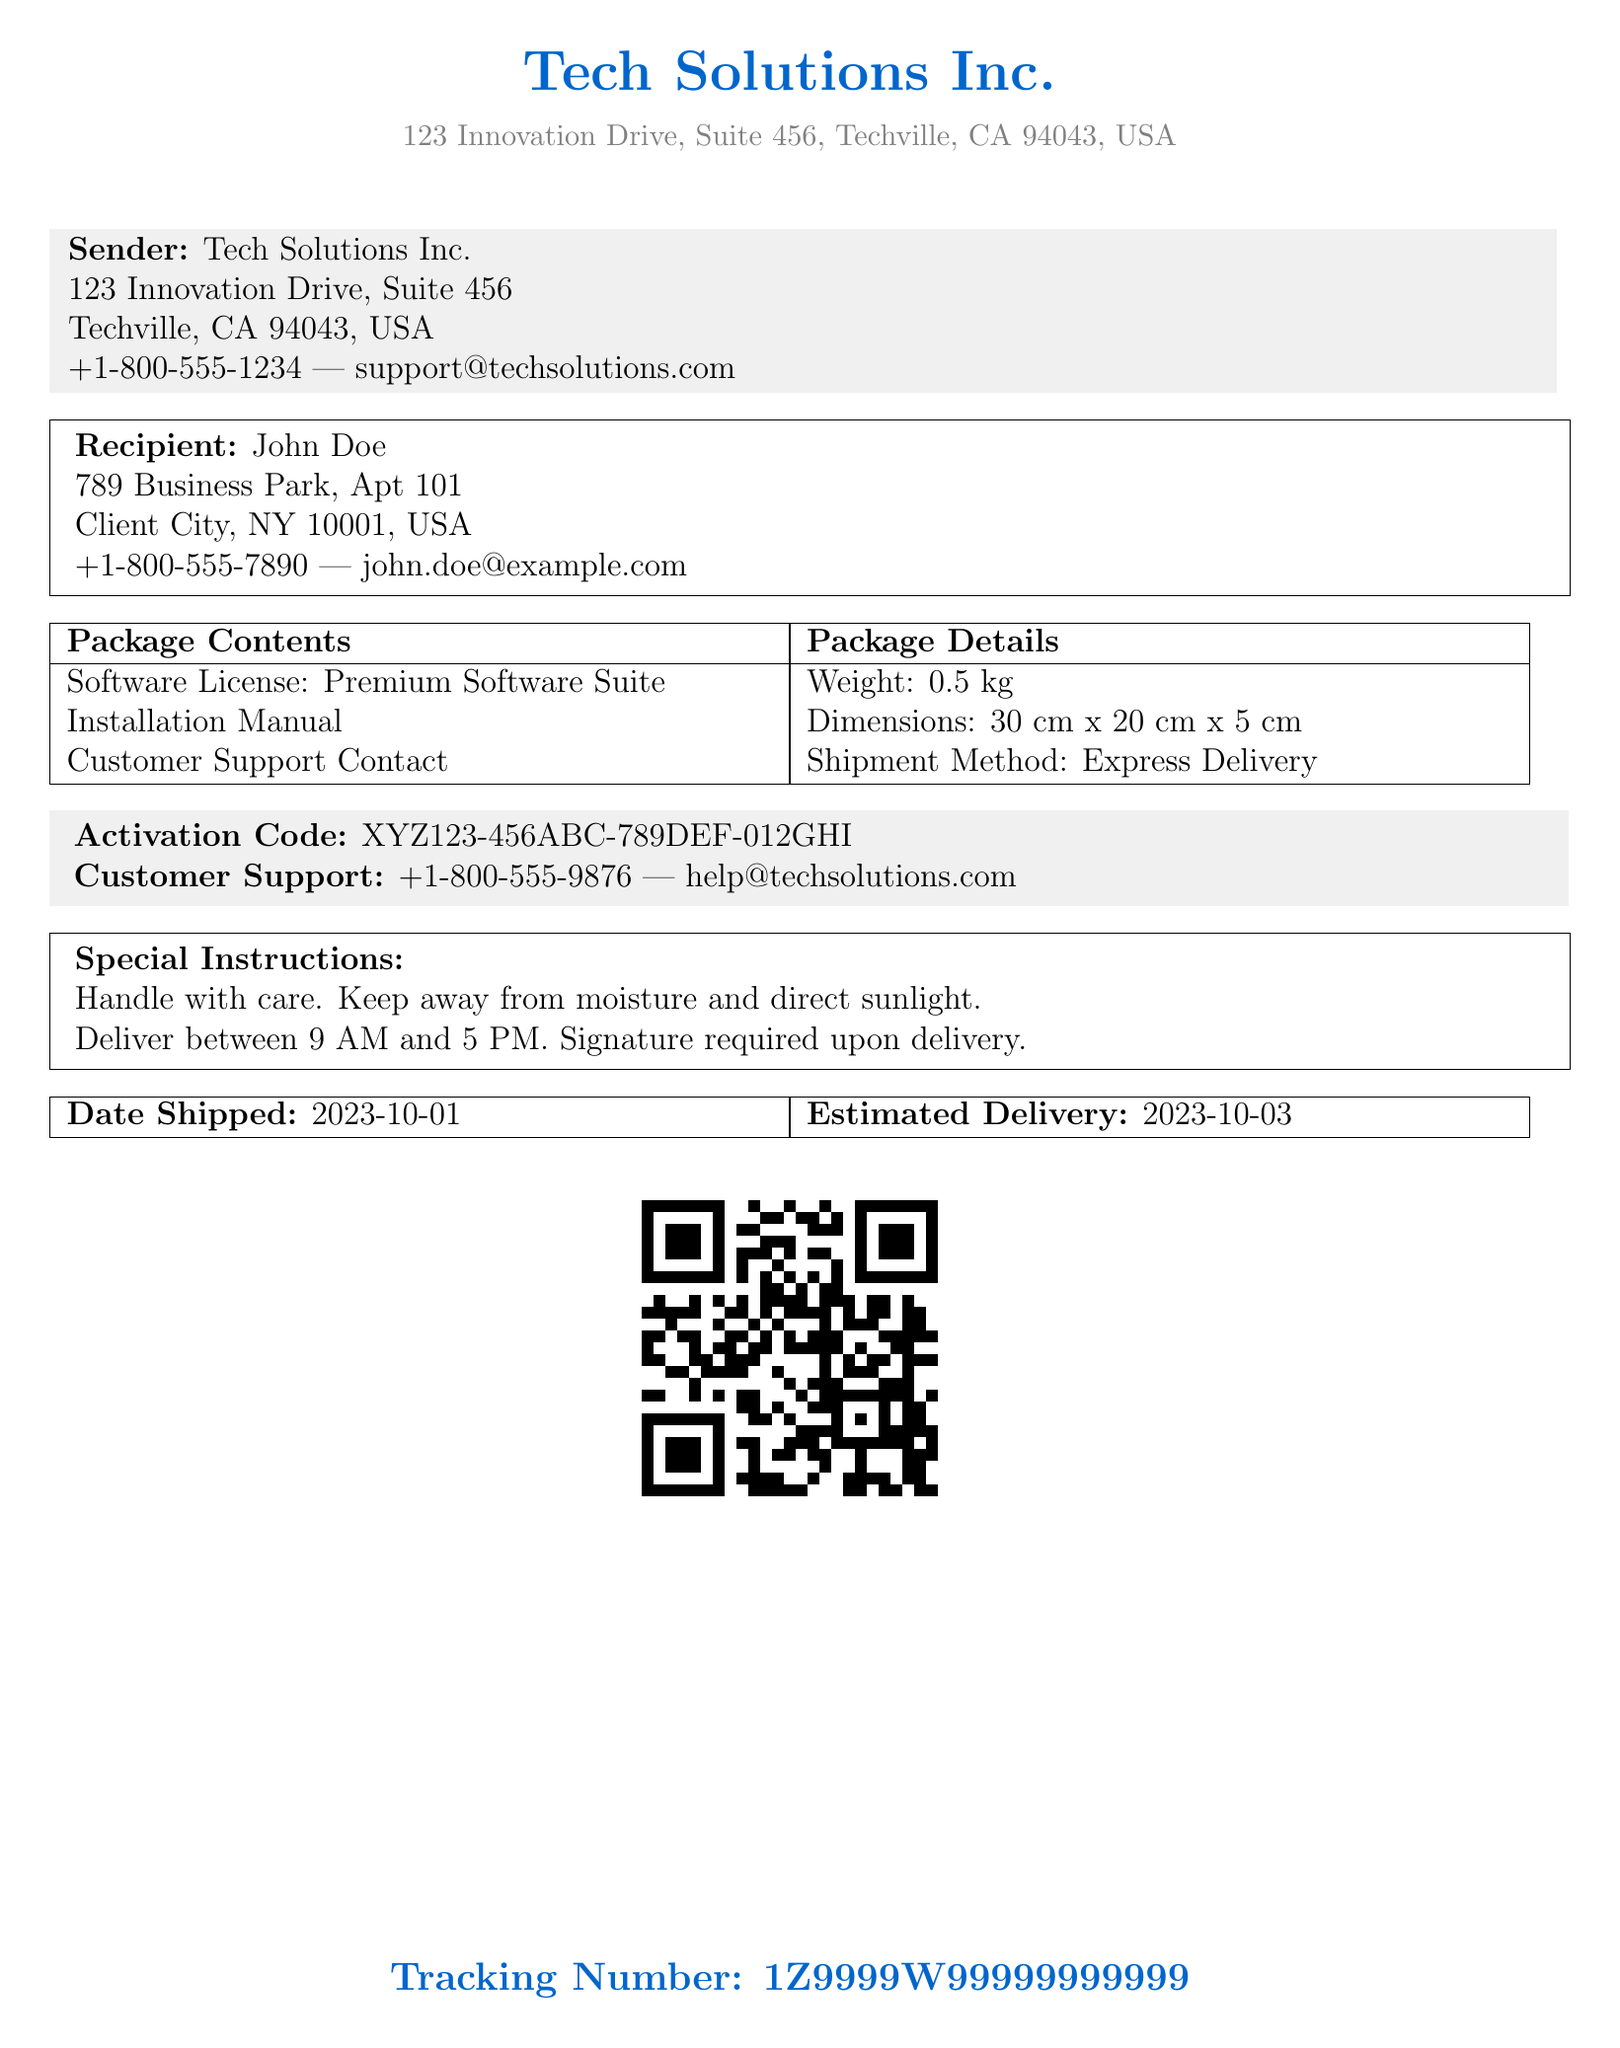What is the sender's address? The sender's address is displayed in the document under sender information as Tech Solutions Inc., 123 Innovation Drive, Suite 456, Techville, CA 94043, USA.
Answer: 123 Innovation Drive, Suite 456, Techville, CA 94043, USA What is the recipient's full name? The full name of the recipient is found in the recipient section of the document.
Answer: John Doe What is the activation code? The activation code is shown in the document in the special instructions section.
Answer: XYZ123-456ABC-789DEF-012GHI What is the weight of the package? The weight of the package can be found in the package details section of the document.
Answer: 0.5 kg What is the estimated delivery date? The estimated delivery date is specified in the document under shipment details.
Answer: 2023-10-03 What are the special instructions for handling the package? The special instructions are outlined in the special instructions section in the document.
Answer: Handle with care. Keep away from moisture and direct sunlight What is the tracking number? The tracking number is specified at the bottom of the document, which is for tracking the shipment.
Answer: 1Z9999W99999999999 What is the shipment method used? The shipment method is stated in the package details section of the document.
Answer: Express Delivery 